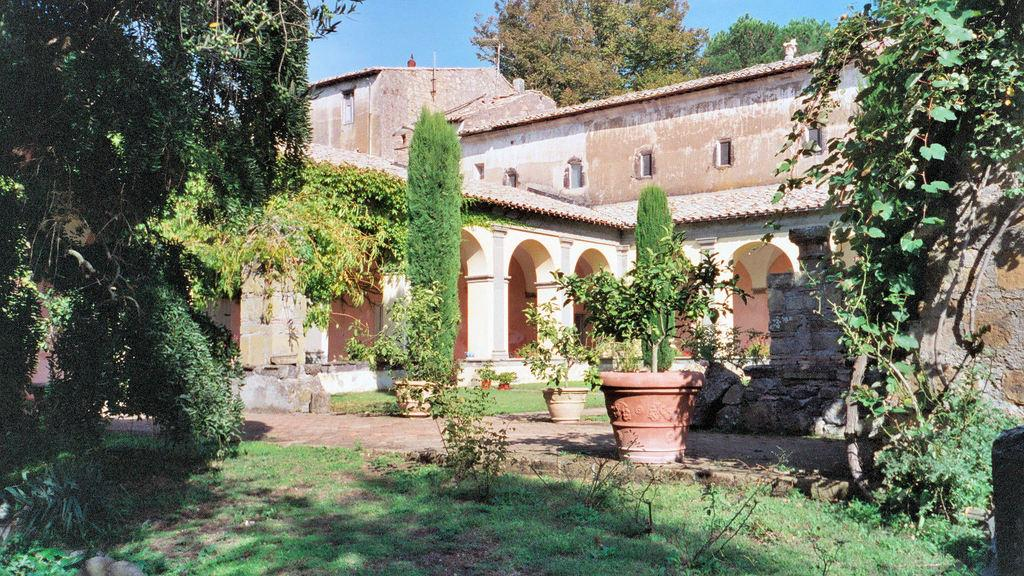What type of structure is present in the image? There is a building in the image. What type of vegetation can be seen in the image? There are trees, plants, and grass. How are the plants arranged in the image? The plants are in plant pots in the image. What is visible in the background of the image? The sky is visible in the background of the image. What type of corn can be seen growing in the image? There is no corn present in the image. What does the temper of the plants in the image indicate? There is no indication of the temper of the plants in the image, as plants do not have emotions. 